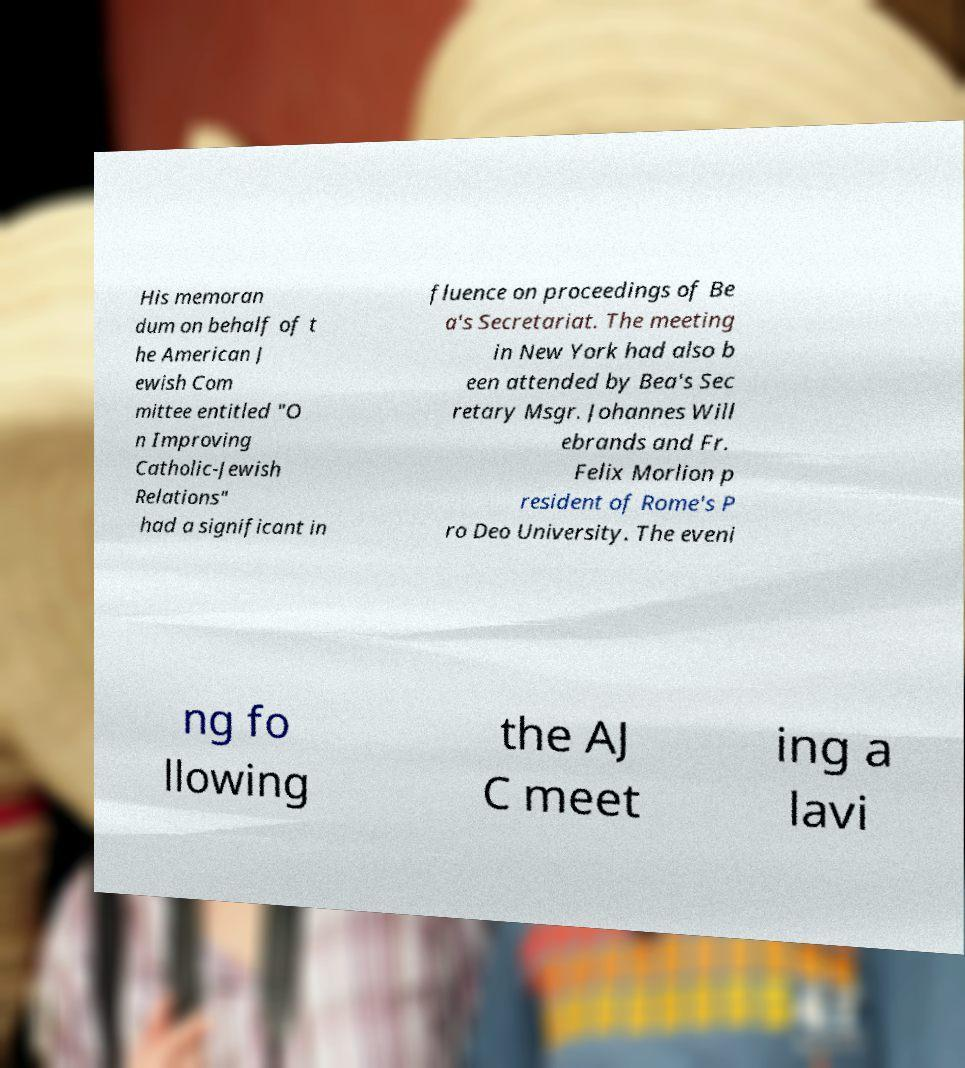Can you accurately transcribe the text from the provided image for me? His memoran dum on behalf of t he American J ewish Com mittee entitled "O n Improving Catholic-Jewish Relations" had a significant in fluence on proceedings of Be a's Secretariat. The meeting in New York had also b een attended by Bea's Sec retary Msgr. Johannes Will ebrands and Fr. Felix Morlion p resident of Rome's P ro Deo University. The eveni ng fo llowing the AJ C meet ing a lavi 